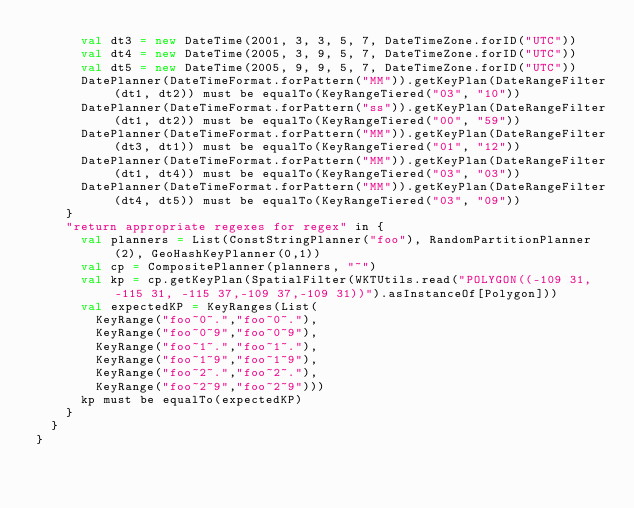<code> <loc_0><loc_0><loc_500><loc_500><_Scala_>      val dt3 = new DateTime(2001, 3, 3, 5, 7, DateTimeZone.forID("UTC"))
      val dt4 = new DateTime(2005, 3, 9, 5, 7, DateTimeZone.forID("UTC"))
      val dt5 = new DateTime(2005, 9, 9, 5, 7, DateTimeZone.forID("UTC"))
      DatePlanner(DateTimeFormat.forPattern("MM")).getKeyPlan(DateRangeFilter(dt1, dt2)) must be equalTo(KeyRangeTiered("03", "10"))
      DatePlanner(DateTimeFormat.forPattern("ss")).getKeyPlan(DateRangeFilter(dt1, dt2)) must be equalTo(KeyRangeTiered("00", "59"))
      DatePlanner(DateTimeFormat.forPattern("MM")).getKeyPlan(DateRangeFilter(dt3, dt1)) must be equalTo(KeyRangeTiered("01", "12"))
      DatePlanner(DateTimeFormat.forPattern("MM")).getKeyPlan(DateRangeFilter(dt1, dt4)) must be equalTo(KeyRangeTiered("03", "03"))
      DatePlanner(DateTimeFormat.forPattern("MM")).getKeyPlan(DateRangeFilter(dt4, dt5)) must be equalTo(KeyRangeTiered("03", "09"))
    }
    "return appropriate regexes for regex" in {
      val planners = List(ConstStringPlanner("foo"), RandomPartitionPlanner(2), GeoHashKeyPlanner(0,1))
      val cp = CompositePlanner(planners, "~")
      val kp = cp.getKeyPlan(SpatialFilter(WKTUtils.read("POLYGON((-109 31, -115 31, -115 37,-109 37,-109 31))").asInstanceOf[Polygon]))
      val expectedKP = KeyRanges(List(
        KeyRange("foo~0~.","foo~0~."),
        KeyRange("foo~0~9","foo~0~9"),
        KeyRange("foo~1~.","foo~1~."),
        KeyRange("foo~1~9","foo~1~9"),
        KeyRange("foo~2~.","foo~2~."),
        KeyRange("foo~2~9","foo~2~9")))
      kp must be equalTo(expectedKP)
    }
  }
}
</code> 